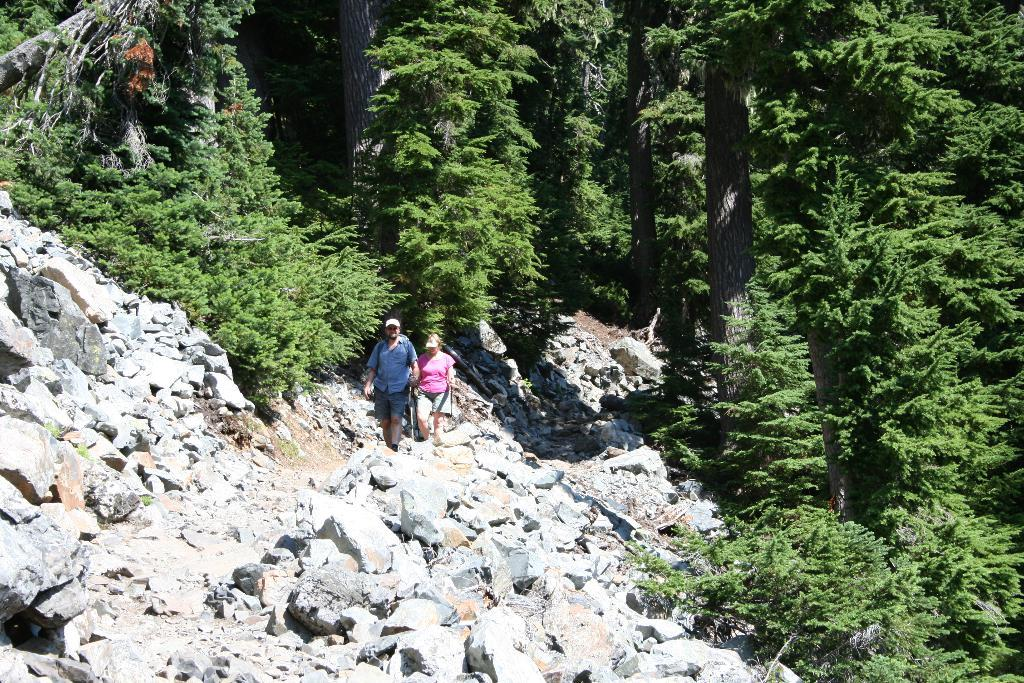What type of vegetation is present in the image? There are a bunch of trees in the image. What else can be seen on the ground in the image? There are stones in the image. Can you describe the activity of the people in the image? Two people are walking in the image. Where is the cellar located in the image? There is no cellar present in the image. What type of bottle can be seen in the hands of the people walking in the image? There is no bottle visible in the image; only the trees, stones, and two people walking are present. 